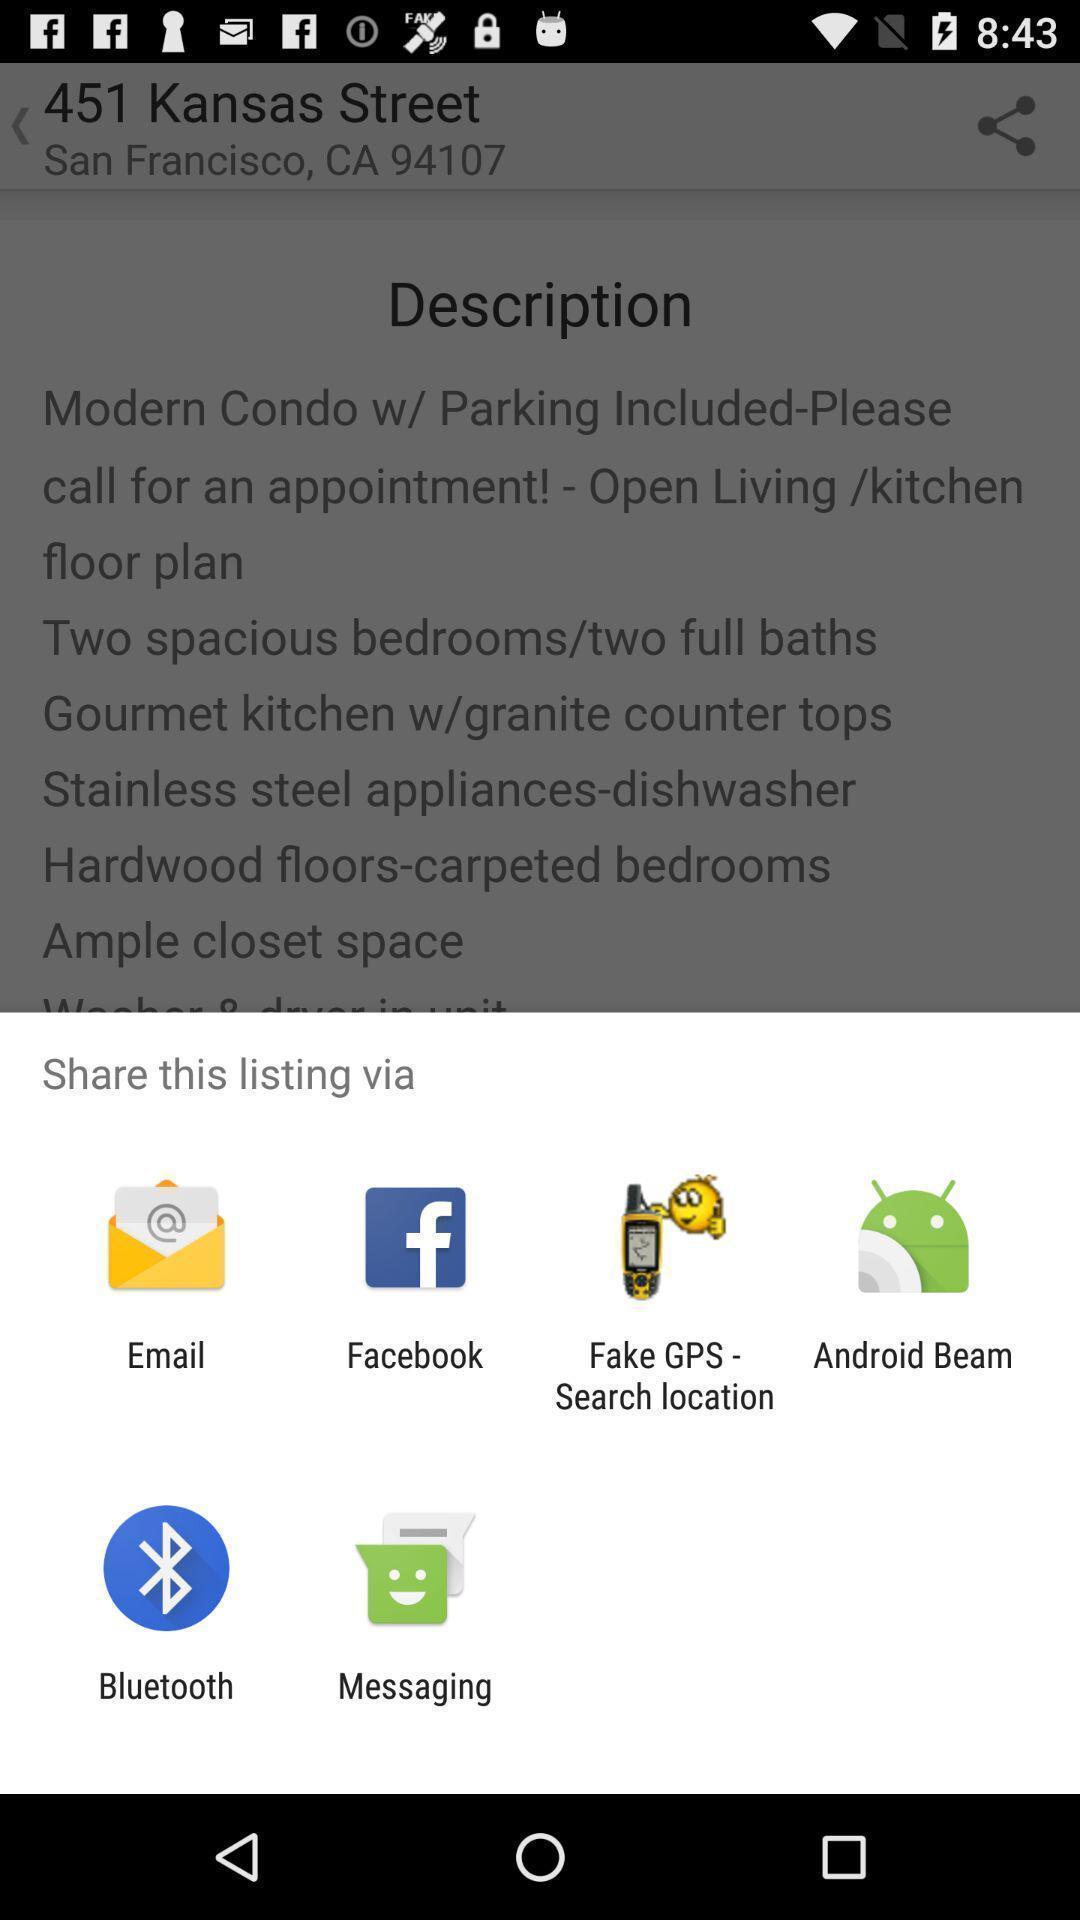Describe the content in this image. Share options page of a property app. 